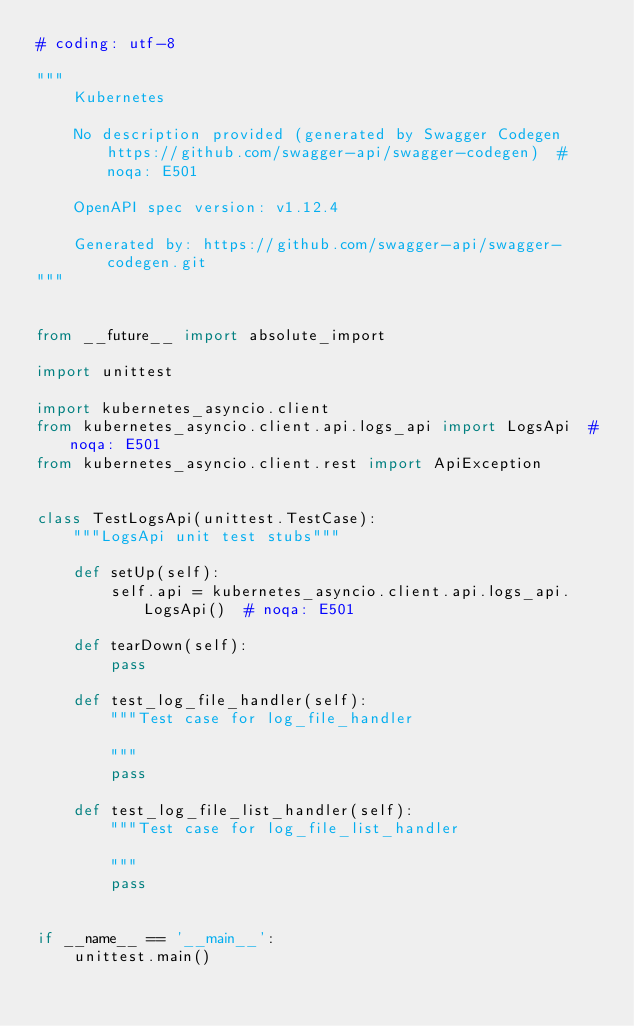Convert code to text. <code><loc_0><loc_0><loc_500><loc_500><_Python_># coding: utf-8

"""
    Kubernetes

    No description provided (generated by Swagger Codegen https://github.com/swagger-api/swagger-codegen)  # noqa: E501

    OpenAPI spec version: v1.12.4
    
    Generated by: https://github.com/swagger-api/swagger-codegen.git
"""


from __future__ import absolute_import

import unittest

import kubernetes_asyncio.client
from kubernetes_asyncio.client.api.logs_api import LogsApi  # noqa: E501
from kubernetes_asyncio.client.rest import ApiException


class TestLogsApi(unittest.TestCase):
    """LogsApi unit test stubs"""

    def setUp(self):
        self.api = kubernetes_asyncio.client.api.logs_api.LogsApi()  # noqa: E501

    def tearDown(self):
        pass

    def test_log_file_handler(self):
        """Test case for log_file_handler

        """
        pass

    def test_log_file_list_handler(self):
        """Test case for log_file_list_handler

        """
        pass


if __name__ == '__main__':
    unittest.main()
</code> 